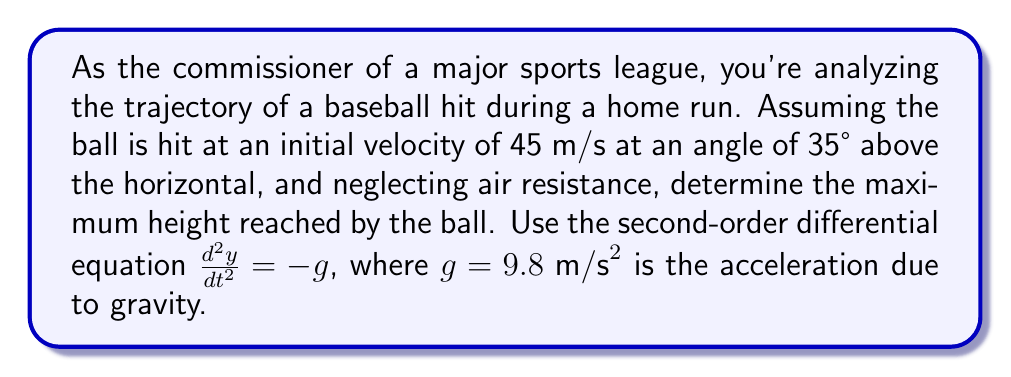Can you answer this question? To solve this problem, we'll use the equations of motion for projectile motion, which are derived from the second-order differential equation $\frac{d^2y}{dt^2} = -g$.

1) First, let's break down the initial velocity into its horizontal and vertical components:
   $v_{0x} = v_0 \cos \theta = 45 \cos 35° \approx 36.87 \text{ m/s}$
   $v_{0y} = v_0 \sin \theta = 45 \sin 35° \approx 25.80 \text{ m/s}$

2) The vertical motion is what determines the maximum height. The equation for vertical velocity as a function of time is:
   $v_y(t) = v_{0y} - gt$

3) At the maximum height, the vertical velocity is zero. So we can find the time to reach maximum height:
   $0 = v_{0y} - gt_{\text{max}}$
   $t_{\text{max}} = \frac{v_{0y}}{g} = \frac{25.80}{9.8} \approx 2.63 \text{ s}$

4) Now we can use the equation for vertical position as a function of time:
   $y(t) = y_0 + v_{0y}t - \frac{1}{2}gt^2$

5) Substituting $t_{\text{max}}$ into this equation (and assuming $y_0 = 0$):
   $y_{\text{max}} = 0 + v_{0y}t_{\text{max}} - \frac{1}{2}gt_{\text{max}}^2$
   $y_{\text{max}} = (25.80)(2.63) - \frac{1}{2}(9.8)(2.63)^2$
   $y_{\text{max}} = 67.85 - 33.93 = 33.92 \text{ m}$

Therefore, the maximum height reached by the baseball is approximately 33.92 meters.
Answer: The maximum height reached by the baseball is approximately 33.92 meters. 